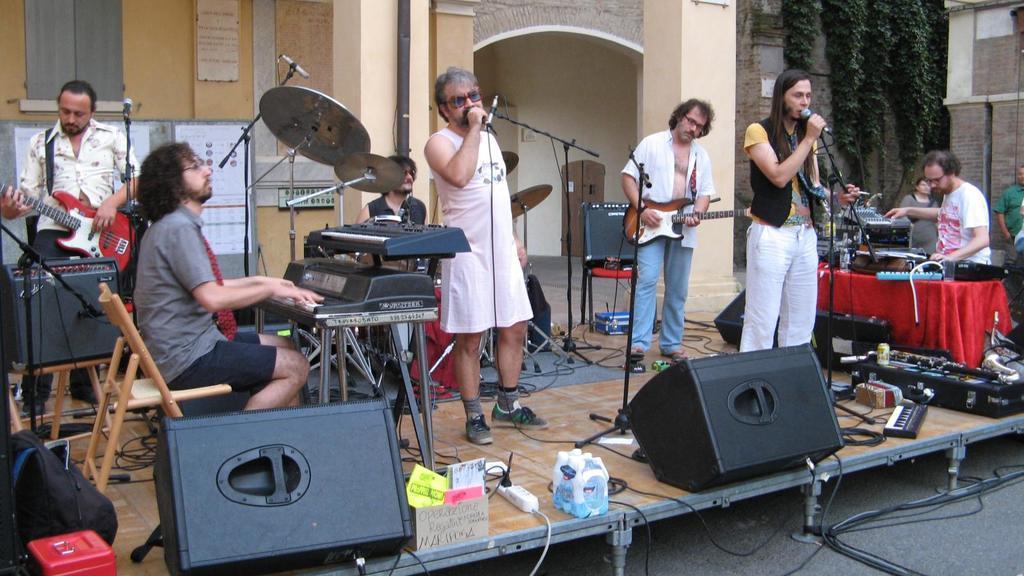In one or two sentences, can you explain what this image depicts? In this image I can see number of people where few of them holding musical instruments in their hands and and also few of them holding mics. In the background I can see a building and few plants. 